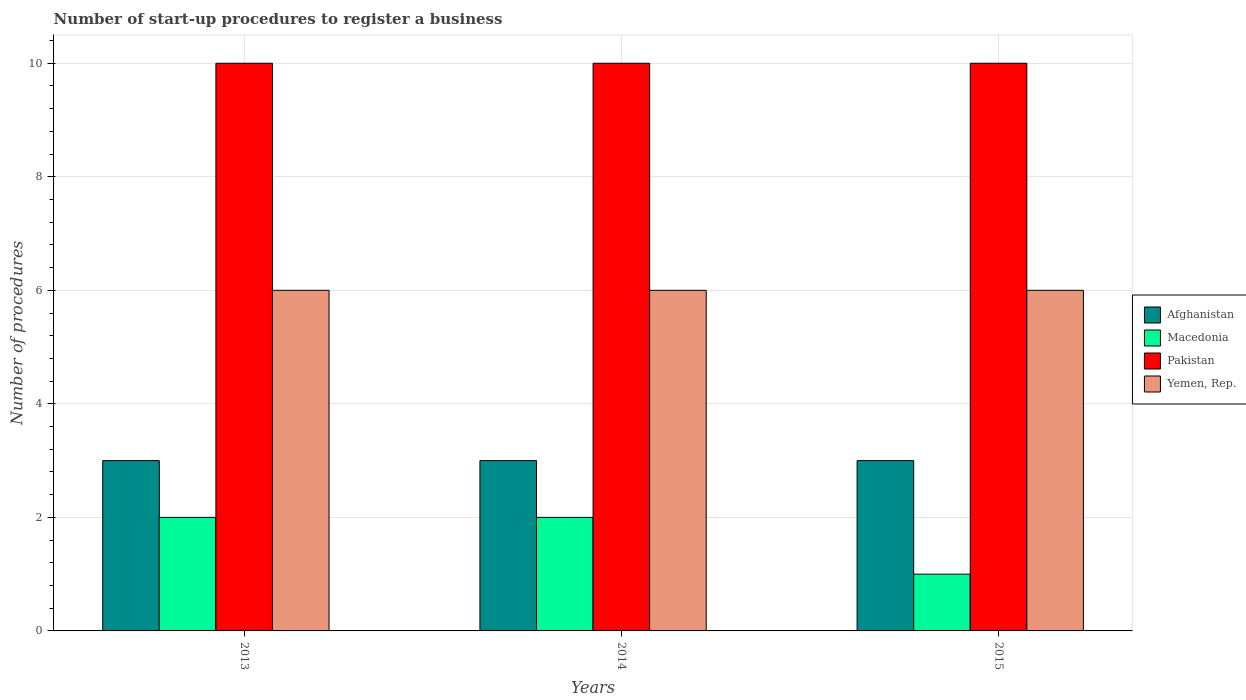Are the number of bars on each tick of the X-axis equal?
Offer a terse response. Yes. How many bars are there on the 3rd tick from the left?
Your answer should be compact. 4. What is the label of the 1st group of bars from the left?
Offer a terse response. 2013. What is the number of procedures required to register a business in Macedonia in 2014?
Give a very brief answer. 2. Across all years, what is the maximum number of procedures required to register a business in Pakistan?
Your answer should be compact. 10. Across all years, what is the minimum number of procedures required to register a business in Pakistan?
Provide a short and direct response. 10. In which year was the number of procedures required to register a business in Afghanistan maximum?
Keep it short and to the point. 2013. In which year was the number of procedures required to register a business in Macedonia minimum?
Your answer should be very brief. 2015. What is the total number of procedures required to register a business in Afghanistan in the graph?
Keep it short and to the point. 9. What is the difference between the number of procedures required to register a business in Macedonia in 2013 and that in 2014?
Make the answer very short. 0. What is the average number of procedures required to register a business in Macedonia per year?
Provide a short and direct response. 1.67. In the year 2013, what is the difference between the number of procedures required to register a business in Yemen, Rep. and number of procedures required to register a business in Afghanistan?
Offer a very short reply. 3. In how many years, is the number of procedures required to register a business in Yemen, Rep. greater than 6?
Your response must be concise. 0. What is the difference between the highest and the lowest number of procedures required to register a business in Afghanistan?
Keep it short and to the point. 0. What does the 4th bar from the left in 2013 represents?
Ensure brevity in your answer.  Yemen, Rep. What does the 4th bar from the right in 2013 represents?
Provide a succinct answer. Afghanistan. How many bars are there?
Give a very brief answer. 12. How many years are there in the graph?
Provide a short and direct response. 3. What is the difference between two consecutive major ticks on the Y-axis?
Provide a short and direct response. 2. Where does the legend appear in the graph?
Give a very brief answer. Center right. How many legend labels are there?
Your answer should be very brief. 4. What is the title of the graph?
Keep it short and to the point. Number of start-up procedures to register a business. What is the label or title of the X-axis?
Ensure brevity in your answer.  Years. What is the label or title of the Y-axis?
Provide a succinct answer. Number of procedures. What is the Number of procedures of Macedonia in 2013?
Provide a succinct answer. 2. What is the Number of procedures in Macedonia in 2014?
Keep it short and to the point. 2. What is the Number of procedures of Yemen, Rep. in 2014?
Ensure brevity in your answer.  6. What is the Number of procedures in Afghanistan in 2015?
Offer a very short reply. 3. What is the Number of procedures of Pakistan in 2015?
Ensure brevity in your answer.  10. What is the Number of procedures in Yemen, Rep. in 2015?
Your answer should be very brief. 6. Across all years, what is the minimum Number of procedures in Afghanistan?
Offer a very short reply. 3. Across all years, what is the minimum Number of procedures of Pakistan?
Your answer should be compact. 10. What is the total Number of procedures in Yemen, Rep. in the graph?
Your response must be concise. 18. What is the difference between the Number of procedures in Yemen, Rep. in 2013 and that in 2014?
Provide a short and direct response. 0. What is the difference between the Number of procedures in Macedonia in 2013 and that in 2015?
Offer a very short reply. 1. What is the difference between the Number of procedures of Pakistan in 2013 and that in 2015?
Provide a short and direct response. 0. What is the difference between the Number of procedures of Pakistan in 2014 and that in 2015?
Keep it short and to the point. 0. What is the difference between the Number of procedures in Yemen, Rep. in 2014 and that in 2015?
Keep it short and to the point. 0. What is the difference between the Number of procedures of Afghanistan in 2013 and the Number of procedures of Yemen, Rep. in 2014?
Make the answer very short. -3. What is the difference between the Number of procedures of Macedonia in 2013 and the Number of procedures of Yemen, Rep. in 2014?
Offer a terse response. -4. What is the difference between the Number of procedures in Pakistan in 2013 and the Number of procedures in Yemen, Rep. in 2014?
Provide a succinct answer. 4. What is the difference between the Number of procedures of Macedonia in 2013 and the Number of procedures of Pakistan in 2015?
Ensure brevity in your answer.  -8. What is the difference between the Number of procedures of Afghanistan in 2014 and the Number of procedures of Yemen, Rep. in 2015?
Your response must be concise. -3. What is the difference between the Number of procedures in Macedonia in 2014 and the Number of procedures in Yemen, Rep. in 2015?
Ensure brevity in your answer.  -4. What is the difference between the Number of procedures in Pakistan in 2014 and the Number of procedures in Yemen, Rep. in 2015?
Keep it short and to the point. 4. What is the average Number of procedures in Macedonia per year?
Your answer should be very brief. 1.67. In the year 2013, what is the difference between the Number of procedures of Afghanistan and Number of procedures of Pakistan?
Offer a very short reply. -7. In the year 2013, what is the difference between the Number of procedures of Afghanistan and Number of procedures of Yemen, Rep.?
Your answer should be very brief. -3. In the year 2013, what is the difference between the Number of procedures in Macedonia and Number of procedures in Pakistan?
Give a very brief answer. -8. In the year 2013, what is the difference between the Number of procedures in Macedonia and Number of procedures in Yemen, Rep.?
Offer a terse response. -4. In the year 2013, what is the difference between the Number of procedures in Pakistan and Number of procedures in Yemen, Rep.?
Provide a succinct answer. 4. In the year 2014, what is the difference between the Number of procedures in Afghanistan and Number of procedures in Macedonia?
Your answer should be compact. 1. In the year 2014, what is the difference between the Number of procedures in Afghanistan and Number of procedures in Pakistan?
Ensure brevity in your answer.  -7. In the year 2014, what is the difference between the Number of procedures of Pakistan and Number of procedures of Yemen, Rep.?
Provide a succinct answer. 4. In the year 2015, what is the difference between the Number of procedures in Afghanistan and Number of procedures in Macedonia?
Provide a succinct answer. 2. In the year 2015, what is the difference between the Number of procedures in Afghanistan and Number of procedures in Pakistan?
Make the answer very short. -7. In the year 2015, what is the difference between the Number of procedures in Afghanistan and Number of procedures in Yemen, Rep.?
Make the answer very short. -3. In the year 2015, what is the difference between the Number of procedures of Macedonia and Number of procedures of Pakistan?
Ensure brevity in your answer.  -9. In the year 2015, what is the difference between the Number of procedures of Macedonia and Number of procedures of Yemen, Rep.?
Offer a terse response. -5. In the year 2015, what is the difference between the Number of procedures of Pakistan and Number of procedures of Yemen, Rep.?
Ensure brevity in your answer.  4. What is the ratio of the Number of procedures in Macedonia in 2013 to that in 2014?
Your answer should be compact. 1. What is the ratio of the Number of procedures in Pakistan in 2013 to that in 2014?
Provide a short and direct response. 1. What is the ratio of the Number of procedures of Macedonia in 2013 to that in 2015?
Offer a terse response. 2. What is the ratio of the Number of procedures in Yemen, Rep. in 2013 to that in 2015?
Your response must be concise. 1. What is the ratio of the Number of procedures in Macedonia in 2014 to that in 2015?
Your response must be concise. 2. What is the ratio of the Number of procedures in Pakistan in 2014 to that in 2015?
Your response must be concise. 1. What is the ratio of the Number of procedures in Yemen, Rep. in 2014 to that in 2015?
Ensure brevity in your answer.  1. What is the difference between the highest and the second highest Number of procedures of Afghanistan?
Provide a succinct answer. 0. What is the difference between the highest and the second highest Number of procedures in Macedonia?
Offer a terse response. 0. What is the difference between the highest and the second highest Number of procedures in Pakistan?
Keep it short and to the point. 0. What is the difference between the highest and the lowest Number of procedures of Afghanistan?
Offer a terse response. 0. What is the difference between the highest and the lowest Number of procedures in Macedonia?
Your response must be concise. 1. What is the difference between the highest and the lowest Number of procedures in Pakistan?
Give a very brief answer. 0. What is the difference between the highest and the lowest Number of procedures in Yemen, Rep.?
Provide a succinct answer. 0. 